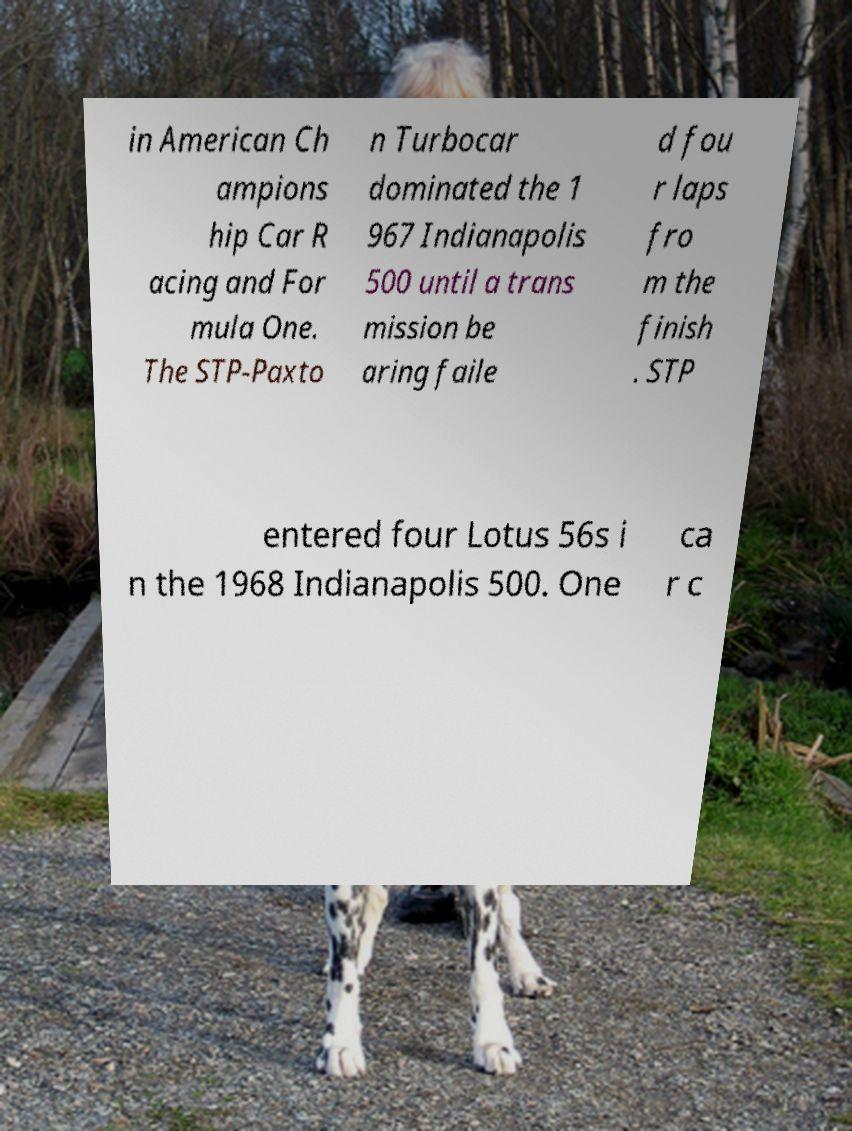What messages or text are displayed in this image? I need them in a readable, typed format. in American Ch ampions hip Car R acing and For mula One. The STP-Paxto n Turbocar dominated the 1 967 Indianapolis 500 until a trans mission be aring faile d fou r laps fro m the finish . STP entered four Lotus 56s i n the 1968 Indianapolis 500. One ca r c 